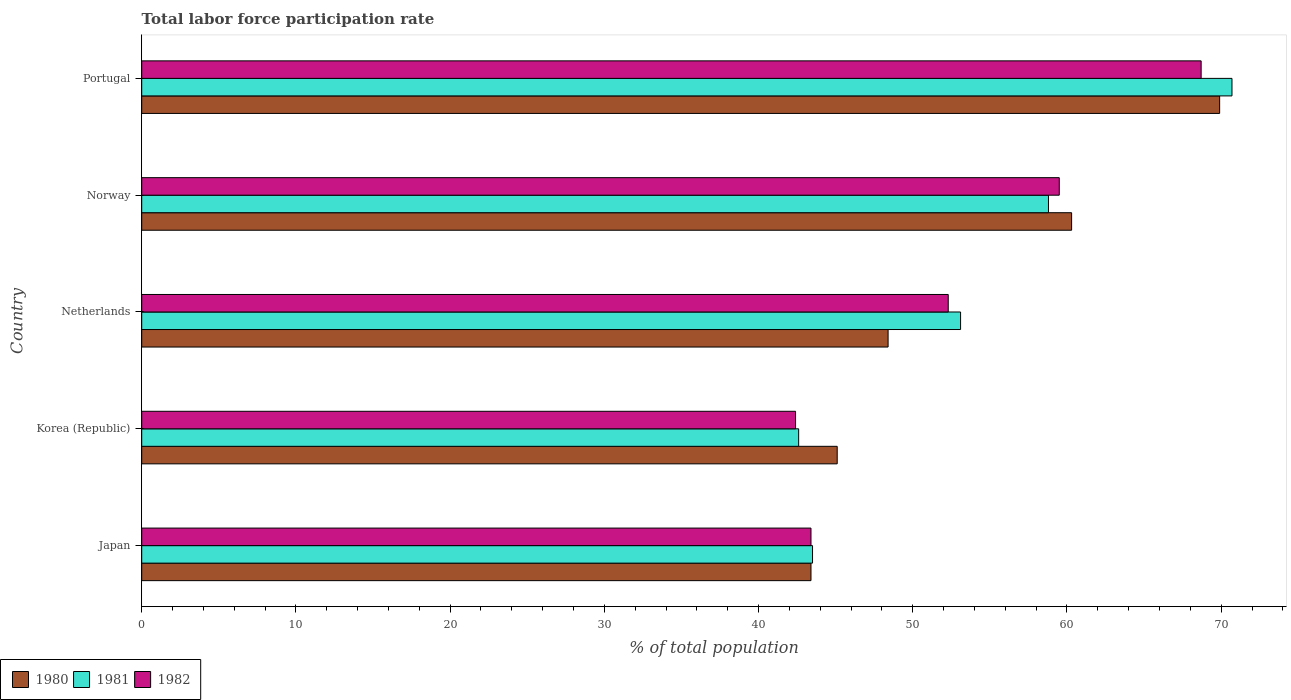What is the label of the 2nd group of bars from the top?
Give a very brief answer. Norway. What is the total labor force participation rate in 1980 in Japan?
Provide a succinct answer. 43.4. Across all countries, what is the maximum total labor force participation rate in 1982?
Offer a terse response. 68.7. Across all countries, what is the minimum total labor force participation rate in 1981?
Ensure brevity in your answer.  42.6. In which country was the total labor force participation rate in 1982 maximum?
Ensure brevity in your answer.  Portugal. What is the total total labor force participation rate in 1981 in the graph?
Provide a short and direct response. 268.7. What is the difference between the total labor force participation rate in 1982 in Japan and that in Portugal?
Your response must be concise. -25.3. What is the difference between the total labor force participation rate in 1981 in Japan and the total labor force participation rate in 1982 in Portugal?
Offer a very short reply. -25.2. What is the average total labor force participation rate in 1981 per country?
Provide a succinct answer. 53.74. What is the difference between the total labor force participation rate in 1980 and total labor force participation rate in 1982 in Korea (Republic)?
Your answer should be very brief. 2.7. In how many countries, is the total labor force participation rate in 1980 greater than 18 %?
Your answer should be very brief. 5. What is the ratio of the total labor force participation rate in 1980 in Japan to that in Norway?
Make the answer very short. 0.72. Is the total labor force participation rate in 1981 in Japan less than that in Netherlands?
Provide a short and direct response. Yes. What is the difference between the highest and the second highest total labor force participation rate in 1980?
Provide a short and direct response. 9.6. What is the difference between the highest and the lowest total labor force participation rate in 1982?
Your answer should be compact. 26.3. Is the sum of the total labor force participation rate in 1982 in Japan and Netherlands greater than the maximum total labor force participation rate in 1981 across all countries?
Make the answer very short. Yes. What does the 3rd bar from the top in Japan represents?
Offer a terse response. 1980. Is it the case that in every country, the sum of the total labor force participation rate in 1980 and total labor force participation rate in 1982 is greater than the total labor force participation rate in 1981?
Your response must be concise. Yes. Are all the bars in the graph horizontal?
Ensure brevity in your answer.  Yes. What is the difference between two consecutive major ticks on the X-axis?
Make the answer very short. 10. Does the graph contain any zero values?
Keep it short and to the point. No. Where does the legend appear in the graph?
Offer a terse response. Bottom left. How are the legend labels stacked?
Offer a very short reply. Horizontal. What is the title of the graph?
Your response must be concise. Total labor force participation rate. What is the label or title of the X-axis?
Provide a short and direct response. % of total population. What is the label or title of the Y-axis?
Offer a terse response. Country. What is the % of total population in 1980 in Japan?
Your response must be concise. 43.4. What is the % of total population of 1981 in Japan?
Keep it short and to the point. 43.5. What is the % of total population of 1982 in Japan?
Provide a succinct answer. 43.4. What is the % of total population of 1980 in Korea (Republic)?
Provide a short and direct response. 45.1. What is the % of total population of 1981 in Korea (Republic)?
Ensure brevity in your answer.  42.6. What is the % of total population in 1982 in Korea (Republic)?
Your answer should be very brief. 42.4. What is the % of total population of 1980 in Netherlands?
Give a very brief answer. 48.4. What is the % of total population in 1981 in Netherlands?
Provide a succinct answer. 53.1. What is the % of total population in 1982 in Netherlands?
Provide a short and direct response. 52.3. What is the % of total population in 1980 in Norway?
Your answer should be compact. 60.3. What is the % of total population in 1981 in Norway?
Offer a terse response. 58.8. What is the % of total population of 1982 in Norway?
Make the answer very short. 59.5. What is the % of total population of 1980 in Portugal?
Keep it short and to the point. 69.9. What is the % of total population in 1981 in Portugal?
Keep it short and to the point. 70.7. What is the % of total population of 1982 in Portugal?
Make the answer very short. 68.7. Across all countries, what is the maximum % of total population in 1980?
Ensure brevity in your answer.  69.9. Across all countries, what is the maximum % of total population in 1981?
Keep it short and to the point. 70.7. Across all countries, what is the maximum % of total population in 1982?
Your response must be concise. 68.7. Across all countries, what is the minimum % of total population of 1980?
Keep it short and to the point. 43.4. Across all countries, what is the minimum % of total population of 1981?
Your answer should be compact. 42.6. Across all countries, what is the minimum % of total population of 1982?
Give a very brief answer. 42.4. What is the total % of total population in 1980 in the graph?
Your response must be concise. 267.1. What is the total % of total population in 1981 in the graph?
Your answer should be compact. 268.7. What is the total % of total population in 1982 in the graph?
Ensure brevity in your answer.  266.3. What is the difference between the % of total population in 1980 in Japan and that in Korea (Republic)?
Offer a very short reply. -1.7. What is the difference between the % of total population of 1981 in Japan and that in Netherlands?
Your response must be concise. -9.6. What is the difference between the % of total population of 1982 in Japan and that in Netherlands?
Provide a succinct answer. -8.9. What is the difference between the % of total population of 1980 in Japan and that in Norway?
Provide a short and direct response. -16.9. What is the difference between the % of total population in 1981 in Japan and that in Norway?
Keep it short and to the point. -15.3. What is the difference between the % of total population of 1982 in Japan and that in Norway?
Offer a terse response. -16.1. What is the difference between the % of total population of 1980 in Japan and that in Portugal?
Make the answer very short. -26.5. What is the difference between the % of total population in 1981 in Japan and that in Portugal?
Ensure brevity in your answer.  -27.2. What is the difference between the % of total population of 1982 in Japan and that in Portugal?
Your answer should be compact. -25.3. What is the difference between the % of total population of 1980 in Korea (Republic) and that in Netherlands?
Provide a succinct answer. -3.3. What is the difference between the % of total population of 1980 in Korea (Republic) and that in Norway?
Make the answer very short. -15.2. What is the difference between the % of total population of 1981 in Korea (Republic) and that in Norway?
Provide a short and direct response. -16.2. What is the difference between the % of total population of 1982 in Korea (Republic) and that in Norway?
Offer a very short reply. -17.1. What is the difference between the % of total population in 1980 in Korea (Republic) and that in Portugal?
Your answer should be very brief. -24.8. What is the difference between the % of total population in 1981 in Korea (Republic) and that in Portugal?
Make the answer very short. -28.1. What is the difference between the % of total population in 1982 in Korea (Republic) and that in Portugal?
Keep it short and to the point. -26.3. What is the difference between the % of total population in 1981 in Netherlands and that in Norway?
Your response must be concise. -5.7. What is the difference between the % of total population in 1980 in Netherlands and that in Portugal?
Ensure brevity in your answer.  -21.5. What is the difference between the % of total population of 1981 in Netherlands and that in Portugal?
Your response must be concise. -17.6. What is the difference between the % of total population of 1982 in Netherlands and that in Portugal?
Offer a terse response. -16.4. What is the difference between the % of total population in 1980 in Japan and the % of total population in 1982 in Korea (Republic)?
Keep it short and to the point. 1. What is the difference between the % of total population of 1981 in Japan and the % of total population of 1982 in Netherlands?
Your answer should be very brief. -8.8. What is the difference between the % of total population in 1980 in Japan and the % of total population in 1981 in Norway?
Offer a very short reply. -15.4. What is the difference between the % of total population of 1980 in Japan and the % of total population of 1982 in Norway?
Provide a succinct answer. -16.1. What is the difference between the % of total population in 1980 in Japan and the % of total population in 1981 in Portugal?
Provide a succinct answer. -27.3. What is the difference between the % of total population in 1980 in Japan and the % of total population in 1982 in Portugal?
Keep it short and to the point. -25.3. What is the difference between the % of total population in 1981 in Japan and the % of total population in 1982 in Portugal?
Give a very brief answer. -25.2. What is the difference between the % of total population in 1980 in Korea (Republic) and the % of total population in 1981 in Netherlands?
Your response must be concise. -8. What is the difference between the % of total population in 1981 in Korea (Republic) and the % of total population in 1982 in Netherlands?
Your response must be concise. -9.7. What is the difference between the % of total population of 1980 in Korea (Republic) and the % of total population of 1981 in Norway?
Provide a short and direct response. -13.7. What is the difference between the % of total population of 1980 in Korea (Republic) and the % of total population of 1982 in Norway?
Provide a succinct answer. -14.4. What is the difference between the % of total population in 1981 in Korea (Republic) and the % of total population in 1982 in Norway?
Ensure brevity in your answer.  -16.9. What is the difference between the % of total population of 1980 in Korea (Republic) and the % of total population of 1981 in Portugal?
Make the answer very short. -25.6. What is the difference between the % of total population of 1980 in Korea (Republic) and the % of total population of 1982 in Portugal?
Your answer should be compact. -23.6. What is the difference between the % of total population in 1981 in Korea (Republic) and the % of total population in 1982 in Portugal?
Your answer should be very brief. -26.1. What is the difference between the % of total population in 1980 in Netherlands and the % of total population in 1981 in Norway?
Offer a very short reply. -10.4. What is the difference between the % of total population of 1980 in Netherlands and the % of total population of 1982 in Norway?
Ensure brevity in your answer.  -11.1. What is the difference between the % of total population in 1981 in Netherlands and the % of total population in 1982 in Norway?
Your answer should be compact. -6.4. What is the difference between the % of total population in 1980 in Netherlands and the % of total population in 1981 in Portugal?
Ensure brevity in your answer.  -22.3. What is the difference between the % of total population in 1980 in Netherlands and the % of total population in 1982 in Portugal?
Ensure brevity in your answer.  -20.3. What is the difference between the % of total population of 1981 in Netherlands and the % of total population of 1982 in Portugal?
Your answer should be very brief. -15.6. What is the difference between the % of total population in 1980 in Norway and the % of total population in 1981 in Portugal?
Your response must be concise. -10.4. What is the difference between the % of total population in 1980 in Norway and the % of total population in 1982 in Portugal?
Your answer should be very brief. -8.4. What is the average % of total population in 1980 per country?
Keep it short and to the point. 53.42. What is the average % of total population of 1981 per country?
Your response must be concise. 53.74. What is the average % of total population of 1982 per country?
Offer a very short reply. 53.26. What is the difference between the % of total population in 1980 and % of total population in 1981 in Japan?
Give a very brief answer. -0.1. What is the difference between the % of total population in 1980 and % of total population in 1982 in Korea (Republic)?
Provide a short and direct response. 2.7. What is the difference between the % of total population of 1981 and % of total population of 1982 in Korea (Republic)?
Your response must be concise. 0.2. What is the difference between the % of total population of 1981 and % of total population of 1982 in Netherlands?
Make the answer very short. 0.8. What is the difference between the % of total population of 1980 and % of total population of 1981 in Norway?
Give a very brief answer. 1.5. What is the difference between the % of total population in 1980 and % of total population in 1982 in Norway?
Offer a terse response. 0.8. What is the difference between the % of total population in 1980 and % of total population in 1981 in Portugal?
Offer a terse response. -0.8. What is the difference between the % of total population in 1981 and % of total population in 1982 in Portugal?
Your answer should be very brief. 2. What is the ratio of the % of total population in 1980 in Japan to that in Korea (Republic)?
Make the answer very short. 0.96. What is the ratio of the % of total population in 1981 in Japan to that in Korea (Republic)?
Make the answer very short. 1.02. What is the ratio of the % of total population in 1982 in Japan to that in Korea (Republic)?
Provide a short and direct response. 1.02. What is the ratio of the % of total population of 1980 in Japan to that in Netherlands?
Your answer should be compact. 0.9. What is the ratio of the % of total population in 1981 in Japan to that in Netherlands?
Make the answer very short. 0.82. What is the ratio of the % of total population in 1982 in Japan to that in Netherlands?
Offer a terse response. 0.83. What is the ratio of the % of total population in 1980 in Japan to that in Norway?
Offer a very short reply. 0.72. What is the ratio of the % of total population in 1981 in Japan to that in Norway?
Keep it short and to the point. 0.74. What is the ratio of the % of total population in 1982 in Japan to that in Norway?
Offer a terse response. 0.73. What is the ratio of the % of total population of 1980 in Japan to that in Portugal?
Give a very brief answer. 0.62. What is the ratio of the % of total population of 1981 in Japan to that in Portugal?
Your answer should be compact. 0.62. What is the ratio of the % of total population in 1982 in Japan to that in Portugal?
Make the answer very short. 0.63. What is the ratio of the % of total population in 1980 in Korea (Republic) to that in Netherlands?
Your answer should be compact. 0.93. What is the ratio of the % of total population of 1981 in Korea (Republic) to that in Netherlands?
Give a very brief answer. 0.8. What is the ratio of the % of total population of 1982 in Korea (Republic) to that in Netherlands?
Offer a very short reply. 0.81. What is the ratio of the % of total population of 1980 in Korea (Republic) to that in Norway?
Your answer should be compact. 0.75. What is the ratio of the % of total population of 1981 in Korea (Republic) to that in Norway?
Offer a terse response. 0.72. What is the ratio of the % of total population in 1982 in Korea (Republic) to that in Norway?
Give a very brief answer. 0.71. What is the ratio of the % of total population in 1980 in Korea (Republic) to that in Portugal?
Make the answer very short. 0.65. What is the ratio of the % of total population in 1981 in Korea (Republic) to that in Portugal?
Your response must be concise. 0.6. What is the ratio of the % of total population in 1982 in Korea (Republic) to that in Portugal?
Your answer should be very brief. 0.62. What is the ratio of the % of total population in 1980 in Netherlands to that in Norway?
Offer a terse response. 0.8. What is the ratio of the % of total population of 1981 in Netherlands to that in Norway?
Provide a succinct answer. 0.9. What is the ratio of the % of total population in 1982 in Netherlands to that in Norway?
Offer a terse response. 0.88. What is the ratio of the % of total population in 1980 in Netherlands to that in Portugal?
Provide a succinct answer. 0.69. What is the ratio of the % of total population of 1981 in Netherlands to that in Portugal?
Provide a short and direct response. 0.75. What is the ratio of the % of total population in 1982 in Netherlands to that in Portugal?
Make the answer very short. 0.76. What is the ratio of the % of total population in 1980 in Norway to that in Portugal?
Your answer should be compact. 0.86. What is the ratio of the % of total population of 1981 in Norway to that in Portugal?
Offer a terse response. 0.83. What is the ratio of the % of total population of 1982 in Norway to that in Portugal?
Make the answer very short. 0.87. What is the difference between the highest and the second highest % of total population in 1981?
Provide a short and direct response. 11.9. What is the difference between the highest and the second highest % of total population in 1982?
Your answer should be compact. 9.2. What is the difference between the highest and the lowest % of total population of 1980?
Offer a very short reply. 26.5. What is the difference between the highest and the lowest % of total population in 1981?
Offer a terse response. 28.1. What is the difference between the highest and the lowest % of total population of 1982?
Give a very brief answer. 26.3. 